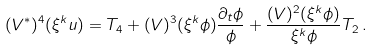Convert formula to latex. <formula><loc_0><loc_0><loc_500><loc_500>( V ^ { \ast } ) ^ { 4 } ( \xi ^ { k } u ) = T _ { 4 } + ( V ) ^ { 3 } ( \xi ^ { k } \phi ) \frac { \partial _ { t } \phi } { \phi } + \frac { ( V ) ^ { 2 } ( \xi ^ { k } \phi ) } { \xi ^ { k } \phi } T _ { 2 } \, .</formula> 